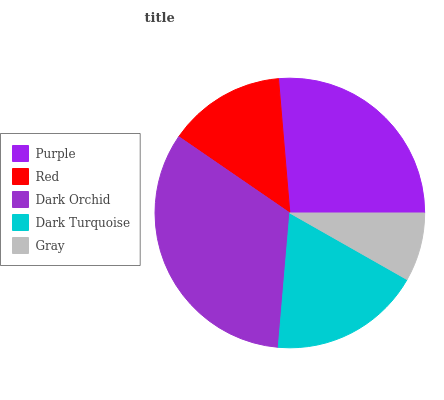Is Gray the minimum?
Answer yes or no. Yes. Is Dark Orchid the maximum?
Answer yes or no. Yes. Is Red the minimum?
Answer yes or no. No. Is Red the maximum?
Answer yes or no. No. Is Purple greater than Red?
Answer yes or no. Yes. Is Red less than Purple?
Answer yes or no. Yes. Is Red greater than Purple?
Answer yes or no. No. Is Purple less than Red?
Answer yes or no. No. Is Dark Turquoise the high median?
Answer yes or no. Yes. Is Dark Turquoise the low median?
Answer yes or no. Yes. Is Purple the high median?
Answer yes or no. No. Is Dark Orchid the low median?
Answer yes or no. No. 